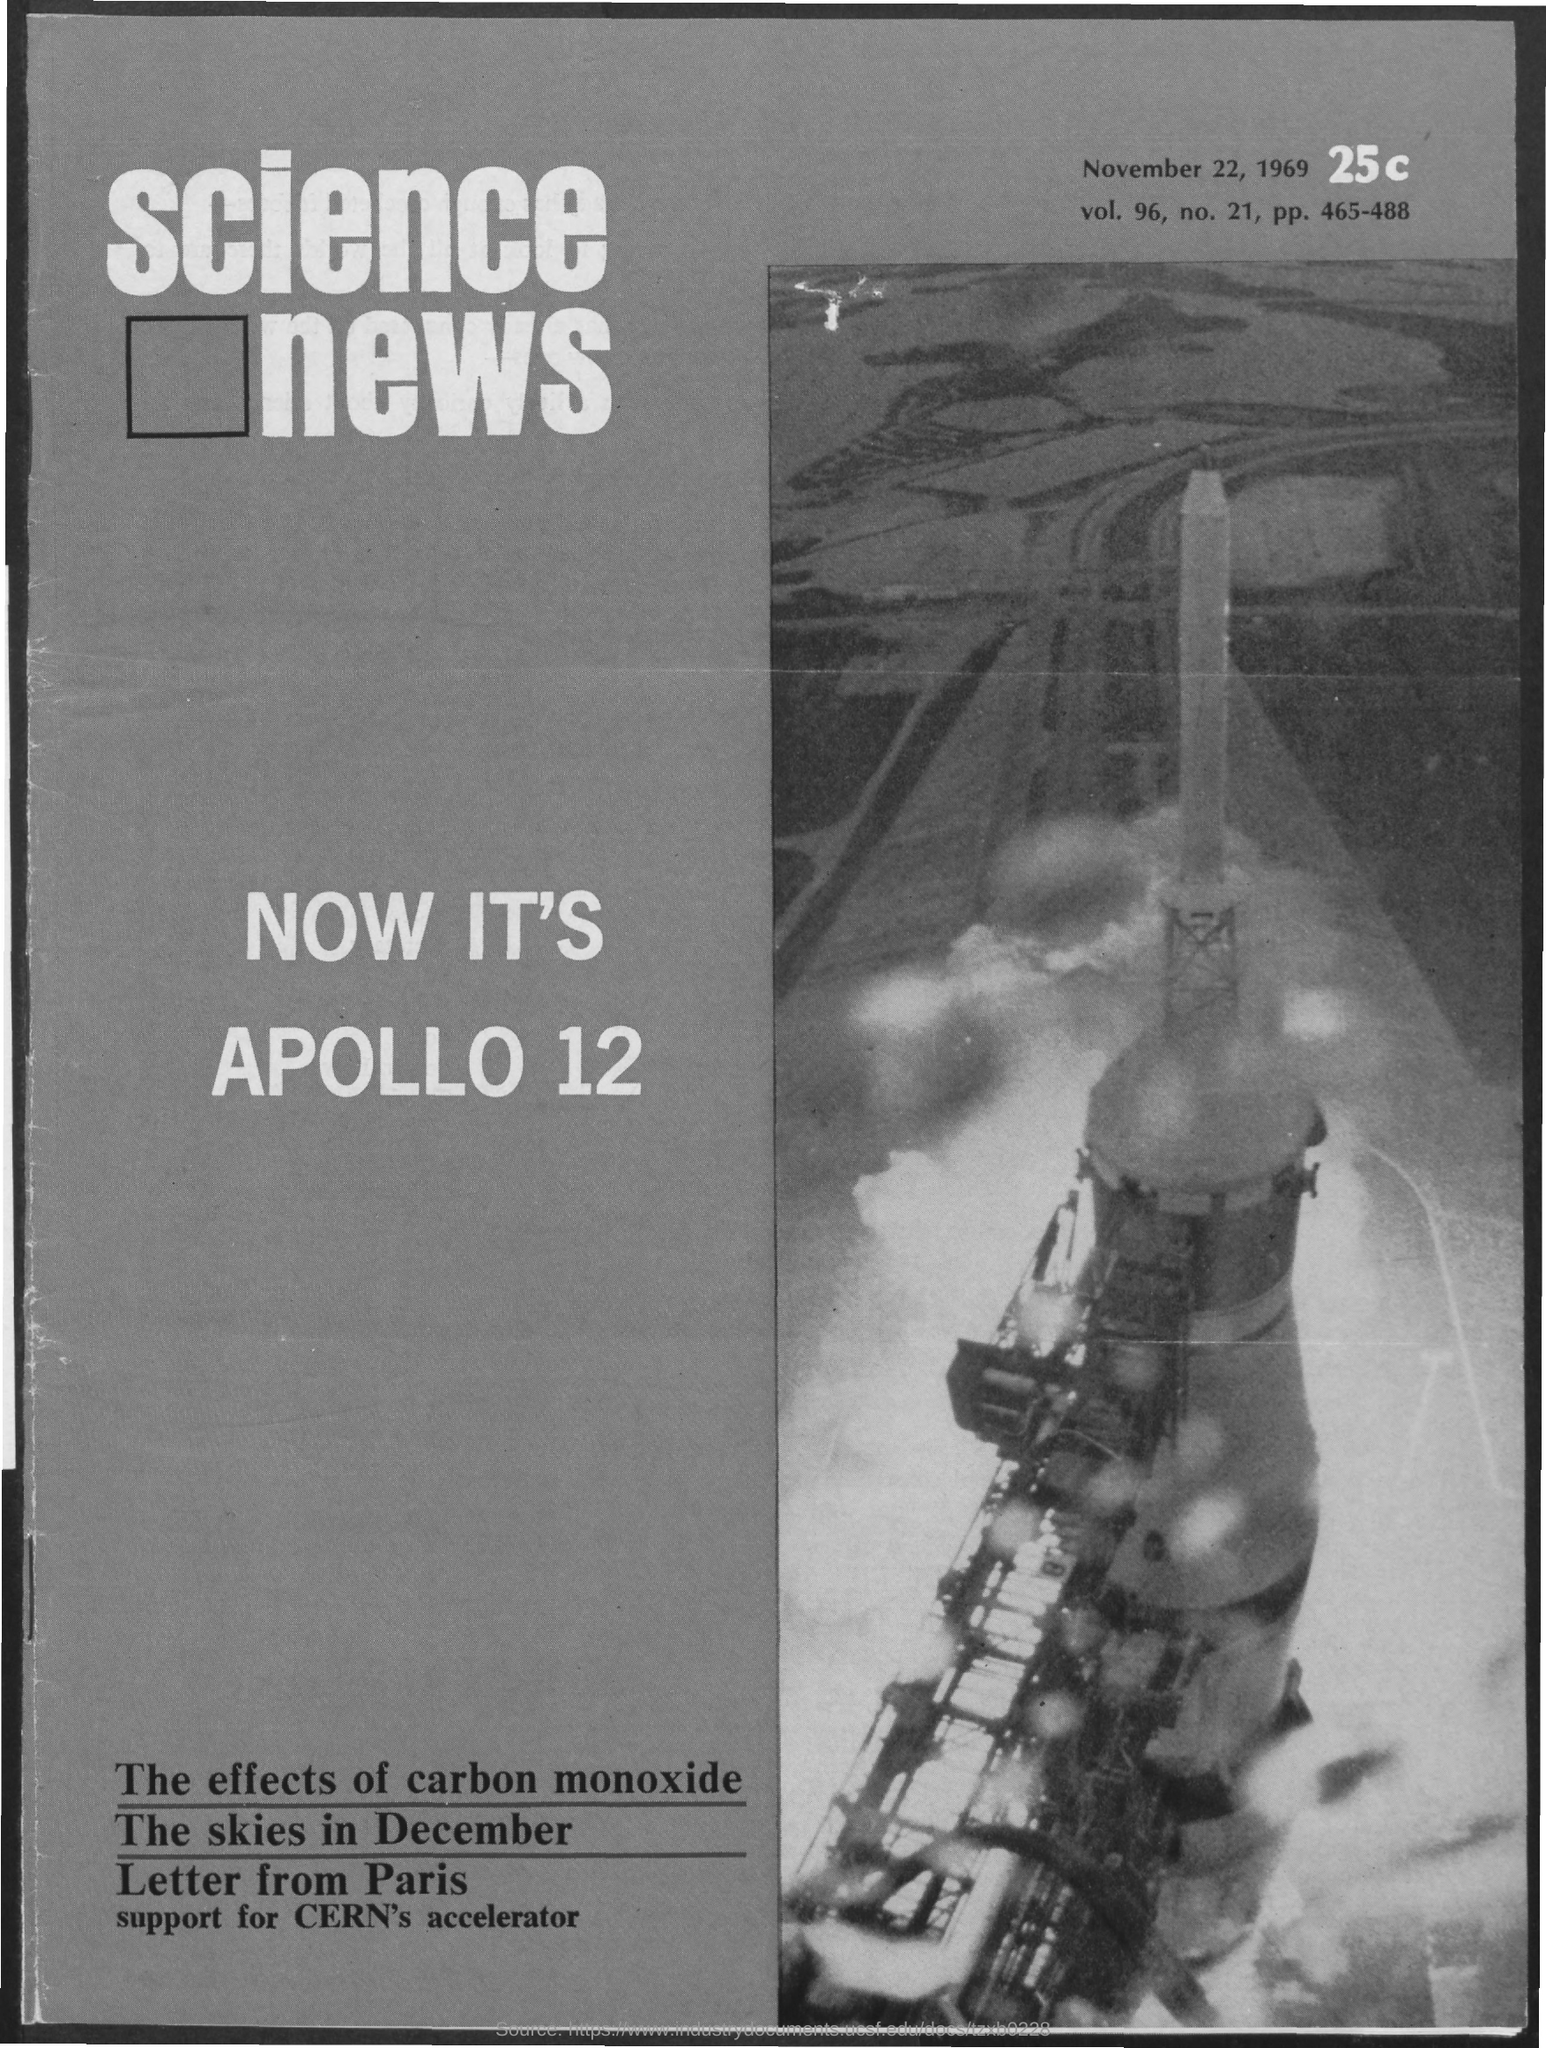Identify some key points in this picture. The volume is 96.. The document indicates that the date is November 22, 1969. The number 21 exists. The pp. is 465-488. 